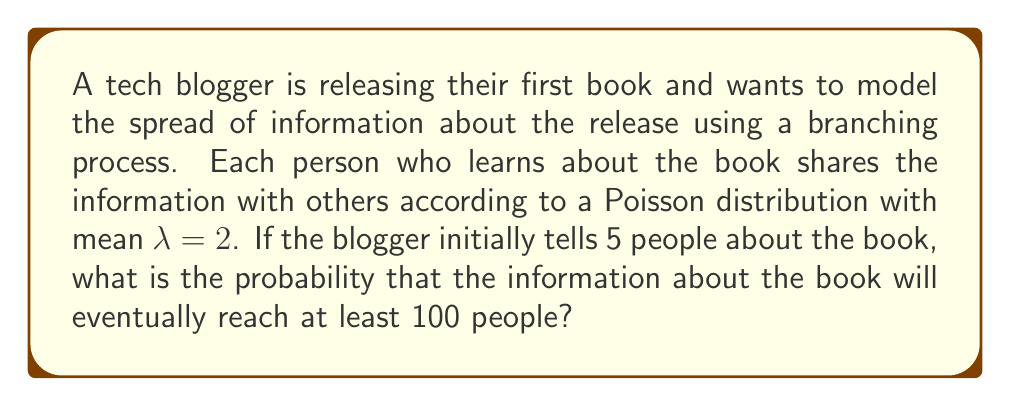Teach me how to tackle this problem. Let's approach this step-by-step:

1) In a branching process, we're interested in the extinction probability, which is the probability that the process will eventually die out.

2) For a Poisson branching process with mean $\lambda$, the extinction probability $q$ satisfies the equation:

   $$q = e^{-\lambda(1-q)}$$

3) In this case, $\lambda = 2$. So we need to solve:

   $$q = e^{-2(1-q)}$$

4) This equation can't be solved analytically, but we can solve it numerically. Using a numerical method (e.g., Newton-Raphson), we find:

   $$q \approx 0.2032$$

5) The probability that the process survives (i.e., doesn't go extinct) when starting with one person is:

   $$1 - q \approx 0.7968$$

6) Now, the blogger starts by telling 5 people. Each of these 5 processes needs to go extinct for the overall process to go extinct. So the probability of extinction when starting with 5 people is:

   $$q^5 \approx 0.2032^5 \approx 0.0003$$

7) Therefore, the probability that the information reaches at least 100 people (i.e., doesn't go extinct) when starting with 5 people is:

   $$1 - q^5 \approx 1 - 0.0003 \approx 0.9997$$
Answer: $0.9997$ 